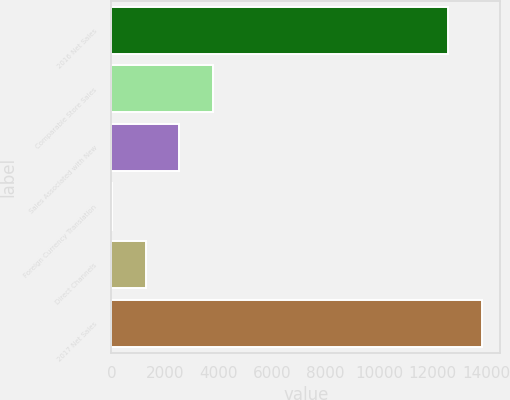Convert chart to OTSL. <chart><loc_0><loc_0><loc_500><loc_500><bar_chart><fcel>2016 Net Sales<fcel>Comparable Store Sales<fcel>Sales Associated with New<fcel>Foreign Currency Translation<fcel>Direct Channels<fcel>2017 Net Sales<nl><fcel>12574<fcel>3799.4<fcel>2537.6<fcel>14<fcel>1275.8<fcel>13835.8<nl></chart> 